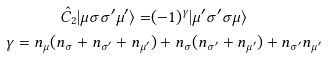Convert formula to latex. <formula><loc_0><loc_0><loc_500><loc_500>\hat { C } _ { 2 } | \mu \sigma \sigma { ^ { \prime } } \mu { ^ { \prime } } \rangle = & ( - 1 ) ^ { \gamma } | \mu { ^ { \prime } } \sigma { ^ { \prime } } \sigma \mu \rangle \\ \gamma = n _ { \mu } ( n _ { \sigma } + n _ { \sigma { ^ { \prime } } } + n _ { \mu { ^ { \prime } } } & ) + n _ { \sigma } ( n _ { \sigma { ^ { \prime } } } + n _ { \mu { ^ { \prime } } } ) + n _ { \sigma { ^ { \prime } } } n _ { \mu { ^ { \prime } } }</formula> 